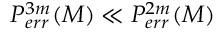Convert formula to latex. <formula><loc_0><loc_0><loc_500><loc_500>P _ { e r r } ^ { 3 m } ( M ) \ll P _ { e r r } ^ { 2 m } ( M )</formula> 